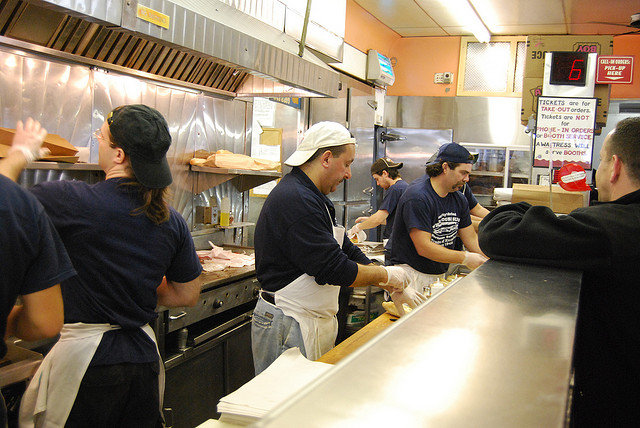Read and extract the text from this image. TAXE orders w IN ORDER NOT 